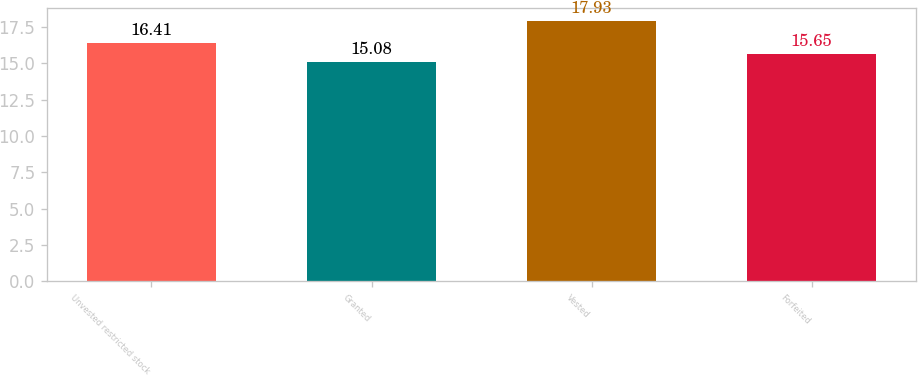Convert chart. <chart><loc_0><loc_0><loc_500><loc_500><bar_chart><fcel>Unvested restricted stock<fcel>Granted<fcel>Vested<fcel>Forfeited<nl><fcel>16.41<fcel>15.08<fcel>17.93<fcel>15.65<nl></chart> 